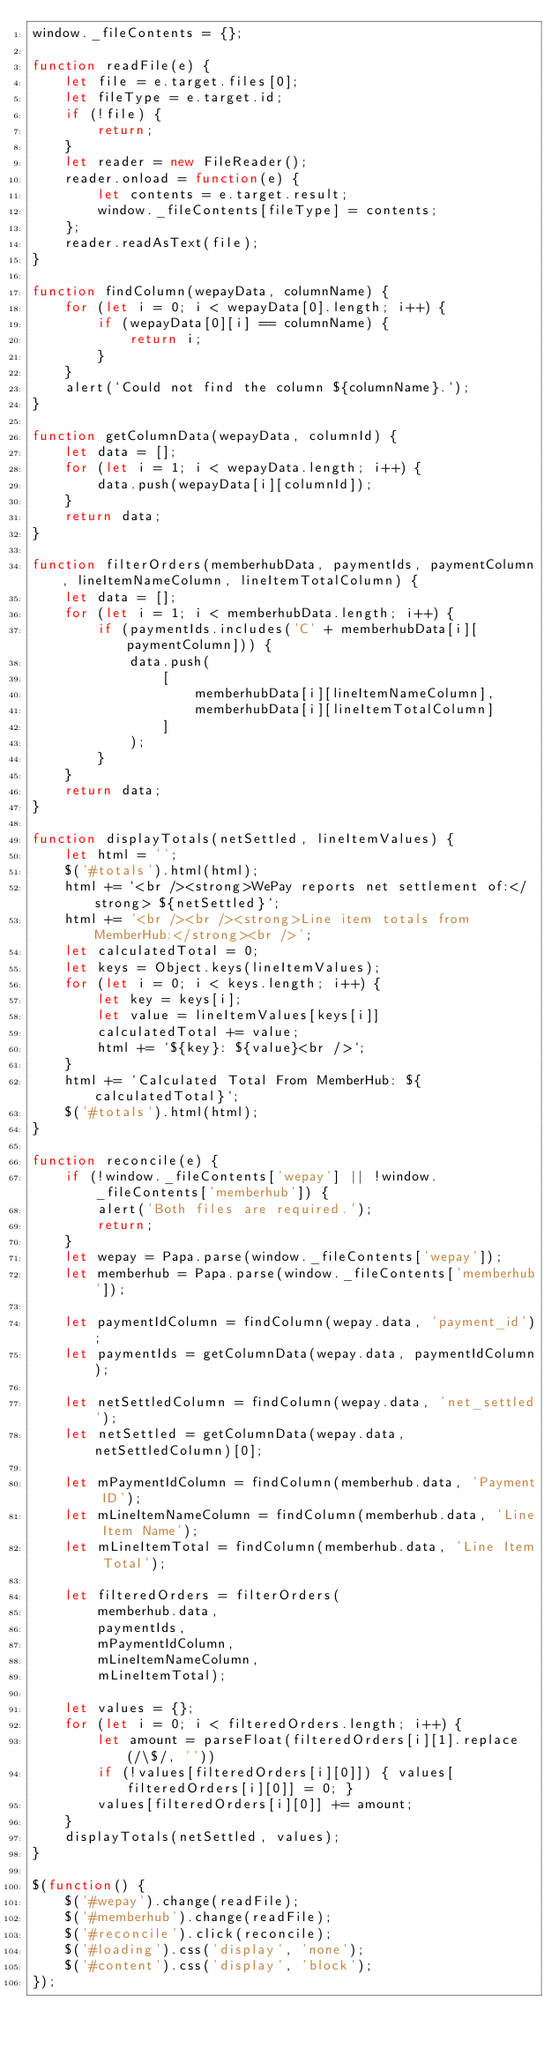Convert code to text. <code><loc_0><loc_0><loc_500><loc_500><_JavaScript_>window._fileContents = {};

function readFile(e) {
    let file = e.target.files[0];
    let fileType = e.target.id;
    if (!file) {
        return;
    }
    let reader = new FileReader();
    reader.onload = function(e) {
        let contents = e.target.result;
        window._fileContents[fileType] = contents;
    };
    reader.readAsText(file);
}

function findColumn(wepayData, columnName) {
    for (let i = 0; i < wepayData[0].length; i++) {
        if (wepayData[0][i] == columnName) {
            return i;
        }
    }
    alert(`Could not find the column ${columnName}.`);
}

function getColumnData(wepayData, columnId) {
    let data = [];
    for (let i = 1; i < wepayData.length; i++) {
        data.push(wepayData[i][columnId]);
    }
    return data;
}

function filterOrders(memberhubData, paymentIds, paymentColumn, lineItemNameColumn, lineItemTotalColumn) {
    let data = [];
    for (let i = 1; i < memberhubData.length; i++) {
        if (paymentIds.includes('C' + memberhubData[i][paymentColumn])) {
            data.push(
                [
                    memberhubData[i][lineItemNameColumn],
                    memberhubData[i][lineItemTotalColumn]
                ]
            );
        }
    }
    return data;
}

function displayTotals(netSettled, lineItemValues) {
    let html = '';
    $('#totals').html(html);
    html += `<br /><strong>WePay reports net settlement of:</strong> ${netSettled}`;
    html += '<br /><br /><strong>Line item totals from MemberHub:</strong><br />';
    let calculatedTotal = 0;
    let keys = Object.keys(lineItemValues);
    for (let i = 0; i < keys.length; i++) {
        let key = keys[i];
        let value = lineItemValues[keys[i]]
        calculatedTotal += value;
        html += `${key}: ${value}<br />`;
    }
    html += `Calculated Total From MemberHub: ${calculatedTotal}`;
    $('#totals').html(html);
}

function reconcile(e) {
    if (!window._fileContents['wepay'] || !window._fileContents['memberhub']) {
        alert('Both files are required.');
        return;
    }
    let wepay = Papa.parse(window._fileContents['wepay']);
    let memberhub = Papa.parse(window._fileContents['memberhub']);

    let paymentIdColumn = findColumn(wepay.data, 'payment_id');
    let paymentIds = getColumnData(wepay.data, paymentIdColumn);

    let netSettledColumn = findColumn(wepay.data, 'net_settled');
    let netSettled = getColumnData(wepay.data, netSettledColumn)[0];

    let mPaymentIdColumn = findColumn(memberhub.data, 'Payment ID');
    let mLineItemNameColumn = findColumn(memberhub.data, 'Line Item Name');
    let mLineItemTotal = findColumn(memberhub.data, 'Line Item Total');

    let filteredOrders = filterOrders(
        memberhub.data,
        paymentIds,
        mPaymentIdColumn,
        mLineItemNameColumn,
        mLineItemTotal);

    let values = {};
    for (let i = 0; i < filteredOrders.length; i++) {
        let amount = parseFloat(filteredOrders[i][1].replace(/\$/, ''))
        if (!values[filteredOrders[i][0]]) { values[filteredOrders[i][0]] = 0; }
        values[filteredOrders[i][0]] += amount;
    }
    displayTotals(netSettled, values);
}

$(function() {
    $('#wepay').change(readFile);
    $('#memberhub').change(readFile);
    $('#reconcile').click(reconcile);
    $('#loading').css('display', 'none');
    $('#content').css('display', 'block');
});</code> 